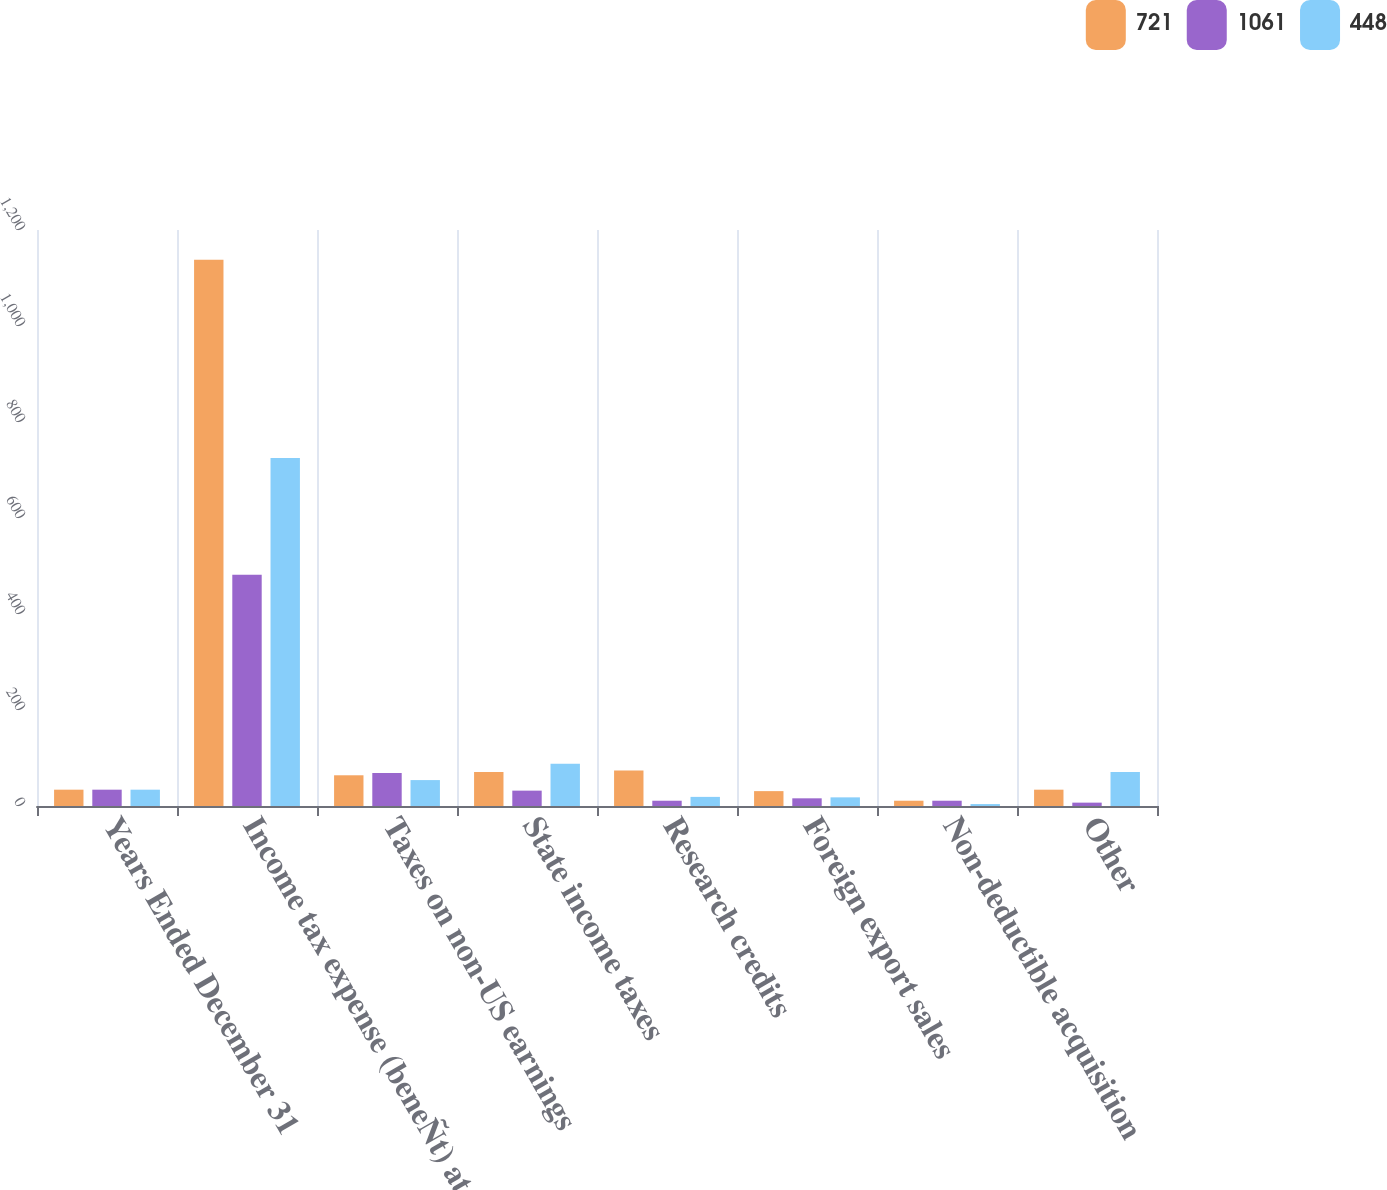Convert chart to OTSL. <chart><loc_0><loc_0><loc_500><loc_500><stacked_bar_chart><ecel><fcel>Years Ended December 31<fcel>Income tax expense (beneÑt) at<fcel>Taxes on non-US earnings<fcel>State income taxes<fcel>Research credits<fcel>Foreign export sales<fcel>Non-deductible acquisition<fcel>Other<nl><fcel>721<fcel>34<fcel>1138<fcel>64<fcel>71<fcel>74<fcel>31<fcel>11<fcel>34<nl><fcel>1061<fcel>34<fcel>482<fcel>69<fcel>32<fcel>11<fcel>16<fcel>11<fcel>7<nl><fcel>448<fcel>34<fcel>725<fcel>54<fcel>88<fcel>19<fcel>18<fcel>4<fcel>71<nl></chart> 